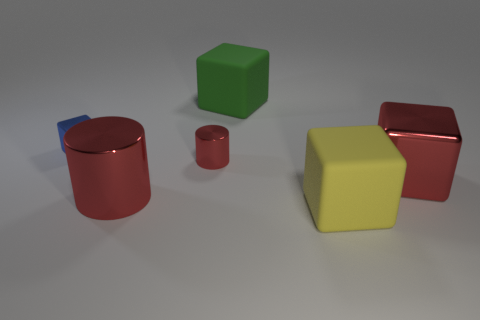Subtract all green cylinders. Subtract all red spheres. How many cylinders are left? 2 Add 1 large rubber cubes. How many objects exist? 7 Subtract all blocks. How many objects are left? 2 Add 3 cubes. How many cubes exist? 7 Subtract 0 brown cylinders. How many objects are left? 6 Subtract all tiny cyan things. Subtract all large red objects. How many objects are left? 4 Add 1 green cubes. How many green cubes are left? 2 